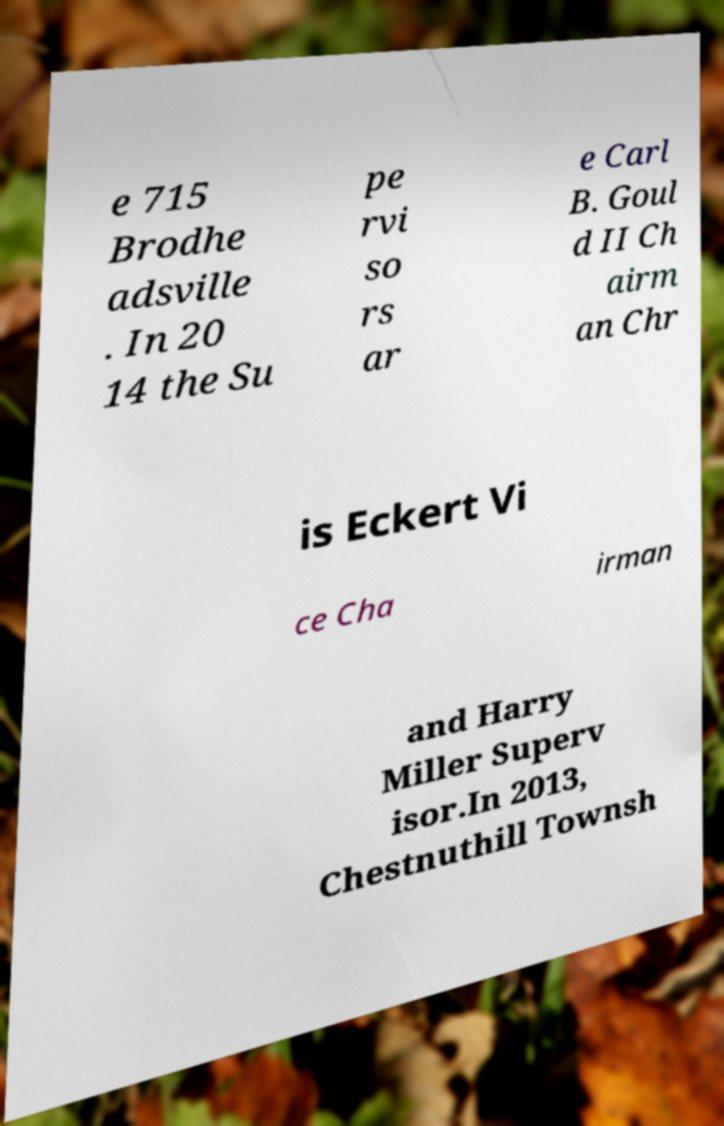There's text embedded in this image that I need extracted. Can you transcribe it verbatim? e 715 Brodhe adsville . In 20 14 the Su pe rvi so rs ar e Carl B. Goul d II Ch airm an Chr is Eckert Vi ce Cha irman and Harry Miller Superv isor.In 2013, Chestnuthill Townsh 